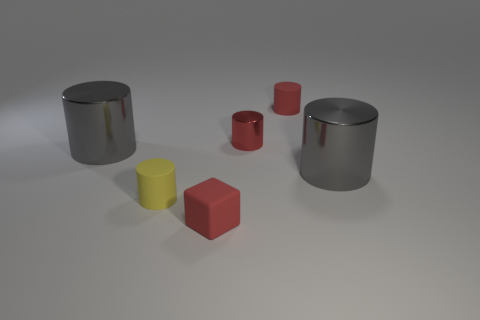Subtract all yellow cylinders. How many cylinders are left? 4 Subtract all red shiny cylinders. How many cylinders are left? 4 Subtract all green cylinders. Subtract all gray blocks. How many cylinders are left? 5 Add 2 cyan metal things. How many objects exist? 8 Subtract all cubes. How many objects are left? 5 Add 2 gray shiny things. How many gray shiny things exist? 4 Subtract 0 purple cubes. How many objects are left? 6 Subtract all big green shiny balls. Subtract all matte blocks. How many objects are left? 5 Add 2 rubber blocks. How many rubber blocks are left? 3 